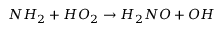<formula> <loc_0><loc_0><loc_500><loc_500>N H _ { 2 } + H O _ { 2 } \rightarrow H _ { 2 } N O + O H</formula> 